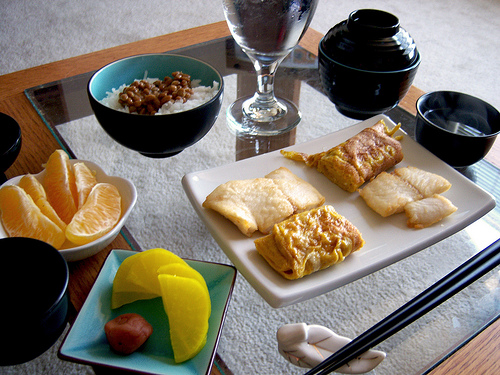<image>
Is the egg to the right of the egg? No. The egg is not to the right of the egg. The horizontal positioning shows a different relationship. Is the glass in the bowl? No. The glass is not contained within the bowl. These objects have a different spatial relationship. 